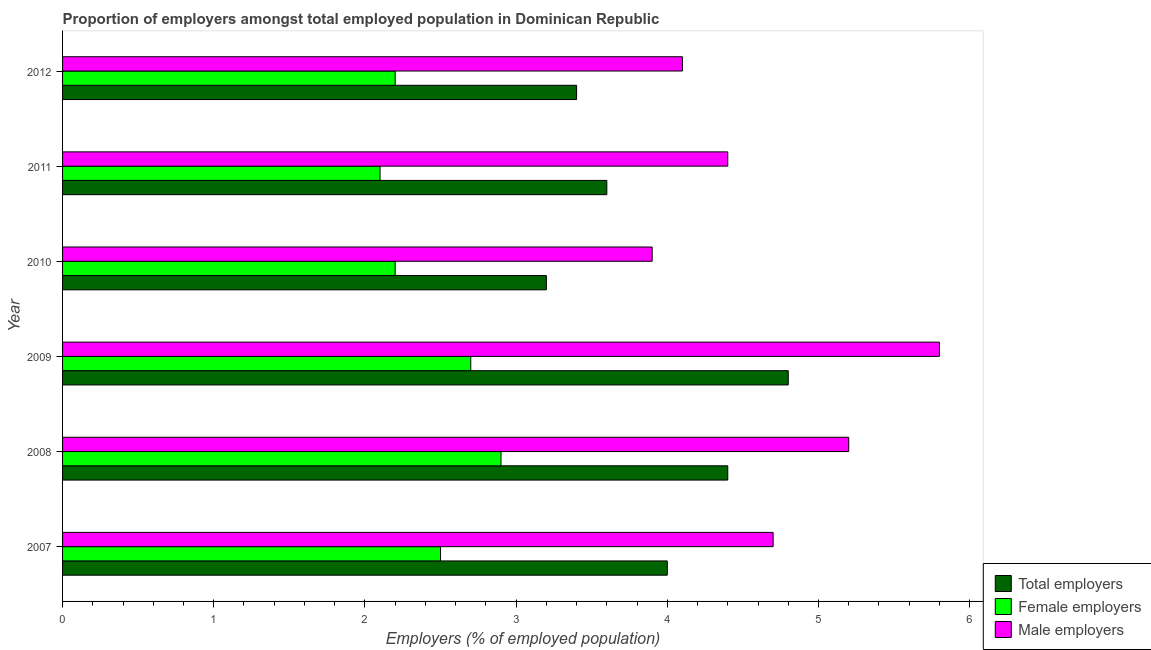How many groups of bars are there?
Give a very brief answer. 6. Are the number of bars per tick equal to the number of legend labels?
Keep it short and to the point. Yes. Are the number of bars on each tick of the Y-axis equal?
Ensure brevity in your answer.  Yes. What is the label of the 5th group of bars from the top?
Offer a very short reply. 2008. In how many cases, is the number of bars for a given year not equal to the number of legend labels?
Ensure brevity in your answer.  0. What is the percentage of male employers in 2011?
Your response must be concise. 4.4. Across all years, what is the maximum percentage of female employers?
Your response must be concise. 2.9. Across all years, what is the minimum percentage of male employers?
Give a very brief answer. 3.9. In which year was the percentage of male employers maximum?
Give a very brief answer. 2009. In which year was the percentage of female employers minimum?
Provide a succinct answer. 2011. What is the total percentage of total employers in the graph?
Your answer should be compact. 23.4. What is the difference between the percentage of female employers in 2011 and the percentage of total employers in 2009?
Your response must be concise. -2.7. What is the average percentage of male employers per year?
Your answer should be compact. 4.68. In how many years, is the percentage of total employers greater than 5.6 %?
Your response must be concise. 0. What is the ratio of the percentage of male employers in 2009 to that in 2010?
Provide a succinct answer. 1.49. What is the difference between the highest and the lowest percentage of total employers?
Provide a short and direct response. 1.6. In how many years, is the percentage of female employers greater than the average percentage of female employers taken over all years?
Ensure brevity in your answer.  3. Is the sum of the percentage of male employers in 2008 and 2010 greater than the maximum percentage of total employers across all years?
Offer a very short reply. Yes. What does the 1st bar from the top in 2009 represents?
Give a very brief answer. Male employers. What does the 2nd bar from the bottom in 2007 represents?
Provide a short and direct response. Female employers. Is it the case that in every year, the sum of the percentage of total employers and percentage of female employers is greater than the percentage of male employers?
Offer a terse response. Yes. How many bars are there?
Provide a succinct answer. 18. Are all the bars in the graph horizontal?
Offer a terse response. Yes. How many years are there in the graph?
Your answer should be very brief. 6. Does the graph contain any zero values?
Provide a succinct answer. No. How many legend labels are there?
Your response must be concise. 3. How are the legend labels stacked?
Provide a short and direct response. Vertical. What is the title of the graph?
Your answer should be very brief. Proportion of employers amongst total employed population in Dominican Republic. Does "Social Protection" appear as one of the legend labels in the graph?
Provide a short and direct response. No. What is the label or title of the X-axis?
Your answer should be very brief. Employers (% of employed population). What is the Employers (% of employed population) in Total employers in 2007?
Offer a very short reply. 4. What is the Employers (% of employed population) of Female employers in 2007?
Provide a succinct answer. 2.5. What is the Employers (% of employed population) of Male employers in 2007?
Give a very brief answer. 4.7. What is the Employers (% of employed population) of Total employers in 2008?
Provide a short and direct response. 4.4. What is the Employers (% of employed population) in Female employers in 2008?
Ensure brevity in your answer.  2.9. What is the Employers (% of employed population) of Male employers in 2008?
Your answer should be compact. 5.2. What is the Employers (% of employed population) of Total employers in 2009?
Your response must be concise. 4.8. What is the Employers (% of employed population) of Female employers in 2009?
Provide a succinct answer. 2.7. What is the Employers (% of employed population) in Male employers in 2009?
Offer a very short reply. 5.8. What is the Employers (% of employed population) in Total employers in 2010?
Provide a succinct answer. 3.2. What is the Employers (% of employed population) of Female employers in 2010?
Offer a very short reply. 2.2. What is the Employers (% of employed population) of Male employers in 2010?
Keep it short and to the point. 3.9. What is the Employers (% of employed population) of Total employers in 2011?
Your answer should be very brief. 3.6. What is the Employers (% of employed population) of Female employers in 2011?
Your answer should be very brief. 2.1. What is the Employers (% of employed population) in Male employers in 2011?
Provide a short and direct response. 4.4. What is the Employers (% of employed population) of Total employers in 2012?
Offer a very short reply. 3.4. What is the Employers (% of employed population) of Female employers in 2012?
Give a very brief answer. 2.2. What is the Employers (% of employed population) in Male employers in 2012?
Keep it short and to the point. 4.1. Across all years, what is the maximum Employers (% of employed population) of Total employers?
Your answer should be compact. 4.8. Across all years, what is the maximum Employers (% of employed population) of Female employers?
Your answer should be very brief. 2.9. Across all years, what is the maximum Employers (% of employed population) in Male employers?
Keep it short and to the point. 5.8. Across all years, what is the minimum Employers (% of employed population) of Total employers?
Provide a short and direct response. 3.2. Across all years, what is the minimum Employers (% of employed population) of Female employers?
Keep it short and to the point. 2.1. Across all years, what is the minimum Employers (% of employed population) in Male employers?
Your answer should be very brief. 3.9. What is the total Employers (% of employed population) of Total employers in the graph?
Offer a terse response. 23.4. What is the total Employers (% of employed population) of Male employers in the graph?
Provide a succinct answer. 28.1. What is the difference between the Employers (% of employed population) of Total employers in 2007 and that in 2009?
Your response must be concise. -0.8. What is the difference between the Employers (% of employed population) in Female employers in 2007 and that in 2009?
Your answer should be compact. -0.2. What is the difference between the Employers (% of employed population) in Total employers in 2007 and that in 2010?
Ensure brevity in your answer.  0.8. What is the difference between the Employers (% of employed population) of Total employers in 2007 and that in 2011?
Offer a very short reply. 0.4. What is the difference between the Employers (% of employed population) in Male employers in 2007 and that in 2011?
Provide a short and direct response. 0.3. What is the difference between the Employers (% of employed population) of Total employers in 2007 and that in 2012?
Offer a terse response. 0.6. What is the difference between the Employers (% of employed population) in Female employers in 2007 and that in 2012?
Offer a very short reply. 0.3. What is the difference between the Employers (% of employed population) of Male employers in 2007 and that in 2012?
Give a very brief answer. 0.6. What is the difference between the Employers (% of employed population) of Total employers in 2008 and that in 2009?
Give a very brief answer. -0.4. What is the difference between the Employers (% of employed population) in Female employers in 2008 and that in 2009?
Ensure brevity in your answer.  0.2. What is the difference between the Employers (% of employed population) in Total employers in 2008 and that in 2010?
Give a very brief answer. 1.2. What is the difference between the Employers (% of employed population) in Female employers in 2008 and that in 2010?
Offer a terse response. 0.7. What is the difference between the Employers (% of employed population) in Male employers in 2008 and that in 2010?
Your response must be concise. 1.3. What is the difference between the Employers (% of employed population) of Female employers in 2008 and that in 2011?
Your response must be concise. 0.8. What is the difference between the Employers (% of employed population) in Female employers in 2008 and that in 2012?
Keep it short and to the point. 0.7. What is the difference between the Employers (% of employed population) of Male employers in 2008 and that in 2012?
Your response must be concise. 1.1. What is the difference between the Employers (% of employed population) of Total employers in 2009 and that in 2010?
Ensure brevity in your answer.  1.6. What is the difference between the Employers (% of employed population) of Female employers in 2009 and that in 2010?
Provide a succinct answer. 0.5. What is the difference between the Employers (% of employed population) in Male employers in 2009 and that in 2010?
Your response must be concise. 1.9. What is the difference between the Employers (% of employed population) of Male employers in 2009 and that in 2012?
Provide a short and direct response. 1.7. What is the difference between the Employers (% of employed population) of Total employers in 2010 and that in 2011?
Ensure brevity in your answer.  -0.4. What is the difference between the Employers (% of employed population) in Female employers in 2010 and that in 2011?
Your answer should be compact. 0.1. What is the difference between the Employers (% of employed population) of Total employers in 2010 and that in 2012?
Offer a very short reply. -0.2. What is the difference between the Employers (% of employed population) of Female employers in 2010 and that in 2012?
Offer a terse response. 0. What is the difference between the Employers (% of employed population) in Total employers in 2011 and that in 2012?
Keep it short and to the point. 0.2. What is the difference between the Employers (% of employed population) in Female employers in 2011 and that in 2012?
Provide a short and direct response. -0.1. What is the difference between the Employers (% of employed population) of Male employers in 2011 and that in 2012?
Make the answer very short. 0.3. What is the difference between the Employers (% of employed population) of Total employers in 2007 and the Employers (% of employed population) of Female employers in 2008?
Provide a succinct answer. 1.1. What is the difference between the Employers (% of employed population) in Female employers in 2007 and the Employers (% of employed population) in Male employers in 2008?
Your answer should be very brief. -2.7. What is the difference between the Employers (% of employed population) in Total employers in 2007 and the Employers (% of employed population) in Female employers in 2009?
Your answer should be compact. 1.3. What is the difference between the Employers (% of employed population) of Total employers in 2007 and the Employers (% of employed population) of Male employers in 2009?
Provide a succinct answer. -1.8. What is the difference between the Employers (% of employed population) in Female employers in 2007 and the Employers (% of employed population) in Male employers in 2009?
Provide a short and direct response. -3.3. What is the difference between the Employers (% of employed population) of Female employers in 2007 and the Employers (% of employed population) of Male employers in 2010?
Make the answer very short. -1.4. What is the difference between the Employers (% of employed population) of Total employers in 2007 and the Employers (% of employed population) of Female employers in 2011?
Provide a succinct answer. 1.9. What is the difference between the Employers (% of employed population) of Total employers in 2007 and the Employers (% of employed population) of Female employers in 2012?
Give a very brief answer. 1.8. What is the difference between the Employers (% of employed population) in Total employers in 2007 and the Employers (% of employed population) in Male employers in 2012?
Your answer should be very brief. -0.1. What is the difference between the Employers (% of employed population) of Total employers in 2008 and the Employers (% of employed population) of Female employers in 2010?
Ensure brevity in your answer.  2.2. What is the difference between the Employers (% of employed population) in Total employers in 2008 and the Employers (% of employed population) in Female employers in 2011?
Offer a terse response. 2.3. What is the difference between the Employers (% of employed population) in Female employers in 2008 and the Employers (% of employed population) in Male employers in 2011?
Ensure brevity in your answer.  -1.5. What is the difference between the Employers (% of employed population) of Total employers in 2008 and the Employers (% of employed population) of Female employers in 2012?
Your answer should be compact. 2.2. What is the difference between the Employers (% of employed population) of Total employers in 2009 and the Employers (% of employed population) of Male employers in 2011?
Offer a very short reply. 0.4. What is the difference between the Employers (% of employed population) of Total employers in 2009 and the Employers (% of employed population) of Male employers in 2012?
Ensure brevity in your answer.  0.7. What is the difference between the Employers (% of employed population) of Total employers in 2010 and the Employers (% of employed population) of Male employers in 2012?
Your answer should be compact. -0.9. What is the difference between the Employers (% of employed population) of Female employers in 2010 and the Employers (% of employed population) of Male employers in 2012?
Keep it short and to the point. -1.9. What is the average Employers (% of employed population) in Female employers per year?
Keep it short and to the point. 2.43. What is the average Employers (% of employed population) in Male employers per year?
Offer a very short reply. 4.68. In the year 2007, what is the difference between the Employers (% of employed population) in Total employers and Employers (% of employed population) in Female employers?
Your response must be concise. 1.5. In the year 2007, what is the difference between the Employers (% of employed population) of Total employers and Employers (% of employed population) of Male employers?
Your response must be concise. -0.7. In the year 2007, what is the difference between the Employers (% of employed population) in Female employers and Employers (% of employed population) in Male employers?
Ensure brevity in your answer.  -2.2. In the year 2008, what is the difference between the Employers (% of employed population) in Total employers and Employers (% of employed population) in Female employers?
Your response must be concise. 1.5. In the year 2008, what is the difference between the Employers (% of employed population) in Female employers and Employers (% of employed population) in Male employers?
Give a very brief answer. -2.3. In the year 2010, what is the difference between the Employers (% of employed population) in Total employers and Employers (% of employed population) in Female employers?
Your answer should be very brief. 1. In the year 2010, what is the difference between the Employers (% of employed population) of Female employers and Employers (% of employed population) of Male employers?
Your response must be concise. -1.7. In the year 2011, what is the difference between the Employers (% of employed population) of Total employers and Employers (% of employed population) of Female employers?
Offer a terse response. 1.5. In the year 2012, what is the difference between the Employers (% of employed population) in Total employers and Employers (% of employed population) in Female employers?
Give a very brief answer. 1.2. In the year 2012, what is the difference between the Employers (% of employed population) in Total employers and Employers (% of employed population) in Male employers?
Offer a very short reply. -0.7. What is the ratio of the Employers (% of employed population) in Female employers in 2007 to that in 2008?
Offer a very short reply. 0.86. What is the ratio of the Employers (% of employed population) in Male employers in 2007 to that in 2008?
Ensure brevity in your answer.  0.9. What is the ratio of the Employers (% of employed population) of Total employers in 2007 to that in 2009?
Provide a short and direct response. 0.83. What is the ratio of the Employers (% of employed population) of Female employers in 2007 to that in 2009?
Give a very brief answer. 0.93. What is the ratio of the Employers (% of employed population) in Male employers in 2007 to that in 2009?
Your answer should be very brief. 0.81. What is the ratio of the Employers (% of employed population) in Female employers in 2007 to that in 2010?
Offer a terse response. 1.14. What is the ratio of the Employers (% of employed population) in Male employers in 2007 to that in 2010?
Your answer should be very brief. 1.21. What is the ratio of the Employers (% of employed population) in Female employers in 2007 to that in 2011?
Provide a short and direct response. 1.19. What is the ratio of the Employers (% of employed population) in Male employers in 2007 to that in 2011?
Ensure brevity in your answer.  1.07. What is the ratio of the Employers (% of employed population) in Total employers in 2007 to that in 2012?
Your response must be concise. 1.18. What is the ratio of the Employers (% of employed population) in Female employers in 2007 to that in 2012?
Provide a succinct answer. 1.14. What is the ratio of the Employers (% of employed population) in Male employers in 2007 to that in 2012?
Your response must be concise. 1.15. What is the ratio of the Employers (% of employed population) of Female employers in 2008 to that in 2009?
Provide a succinct answer. 1.07. What is the ratio of the Employers (% of employed population) in Male employers in 2008 to that in 2009?
Provide a short and direct response. 0.9. What is the ratio of the Employers (% of employed population) of Total employers in 2008 to that in 2010?
Give a very brief answer. 1.38. What is the ratio of the Employers (% of employed population) in Female employers in 2008 to that in 2010?
Offer a very short reply. 1.32. What is the ratio of the Employers (% of employed population) of Total employers in 2008 to that in 2011?
Give a very brief answer. 1.22. What is the ratio of the Employers (% of employed population) in Female employers in 2008 to that in 2011?
Offer a terse response. 1.38. What is the ratio of the Employers (% of employed population) of Male employers in 2008 to that in 2011?
Ensure brevity in your answer.  1.18. What is the ratio of the Employers (% of employed population) in Total employers in 2008 to that in 2012?
Your answer should be very brief. 1.29. What is the ratio of the Employers (% of employed population) of Female employers in 2008 to that in 2012?
Ensure brevity in your answer.  1.32. What is the ratio of the Employers (% of employed population) in Male employers in 2008 to that in 2012?
Give a very brief answer. 1.27. What is the ratio of the Employers (% of employed population) of Female employers in 2009 to that in 2010?
Your response must be concise. 1.23. What is the ratio of the Employers (% of employed population) in Male employers in 2009 to that in 2010?
Make the answer very short. 1.49. What is the ratio of the Employers (% of employed population) in Total employers in 2009 to that in 2011?
Offer a very short reply. 1.33. What is the ratio of the Employers (% of employed population) in Female employers in 2009 to that in 2011?
Ensure brevity in your answer.  1.29. What is the ratio of the Employers (% of employed population) in Male employers in 2009 to that in 2011?
Keep it short and to the point. 1.32. What is the ratio of the Employers (% of employed population) in Total employers in 2009 to that in 2012?
Offer a terse response. 1.41. What is the ratio of the Employers (% of employed population) in Female employers in 2009 to that in 2012?
Give a very brief answer. 1.23. What is the ratio of the Employers (% of employed population) in Male employers in 2009 to that in 2012?
Your response must be concise. 1.41. What is the ratio of the Employers (% of employed population) of Female employers in 2010 to that in 2011?
Your response must be concise. 1.05. What is the ratio of the Employers (% of employed population) in Male employers in 2010 to that in 2011?
Provide a succinct answer. 0.89. What is the ratio of the Employers (% of employed population) of Female employers in 2010 to that in 2012?
Give a very brief answer. 1. What is the ratio of the Employers (% of employed population) in Male employers in 2010 to that in 2012?
Ensure brevity in your answer.  0.95. What is the ratio of the Employers (% of employed population) of Total employers in 2011 to that in 2012?
Provide a succinct answer. 1.06. What is the ratio of the Employers (% of employed population) in Female employers in 2011 to that in 2012?
Provide a short and direct response. 0.95. What is the ratio of the Employers (% of employed population) of Male employers in 2011 to that in 2012?
Offer a very short reply. 1.07. What is the difference between the highest and the second highest Employers (% of employed population) in Female employers?
Your response must be concise. 0.2. What is the difference between the highest and the lowest Employers (% of employed population) in Total employers?
Your answer should be compact. 1.6. What is the difference between the highest and the lowest Employers (% of employed population) of Female employers?
Make the answer very short. 0.8. What is the difference between the highest and the lowest Employers (% of employed population) of Male employers?
Provide a succinct answer. 1.9. 